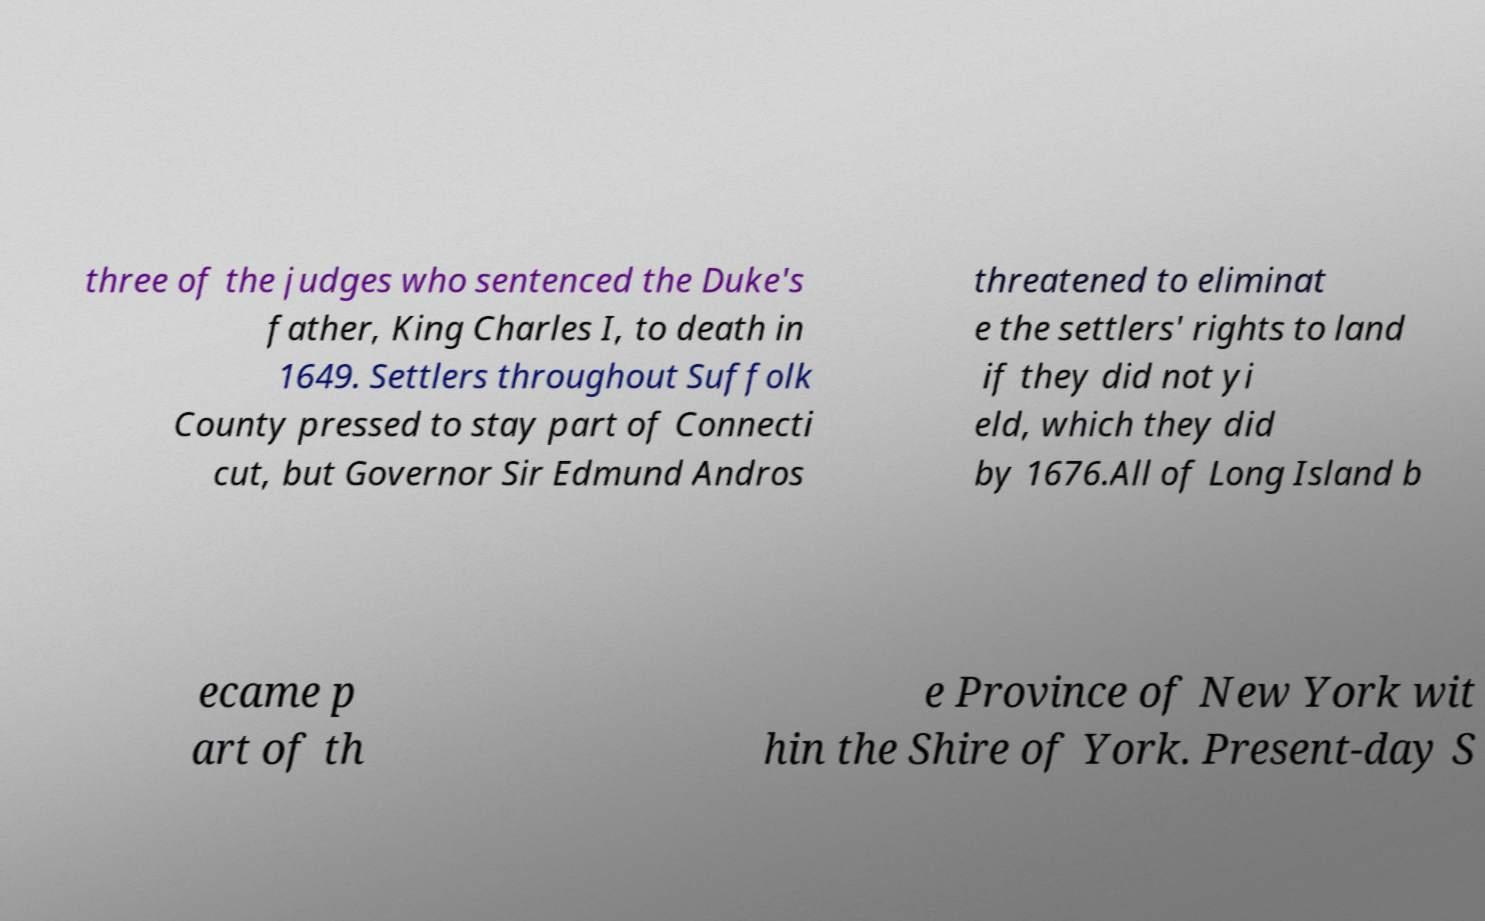Can you accurately transcribe the text from the provided image for me? three of the judges who sentenced the Duke's father, King Charles I, to death in 1649. Settlers throughout Suffolk County pressed to stay part of Connecti cut, but Governor Sir Edmund Andros threatened to eliminat e the settlers' rights to land if they did not yi eld, which they did by 1676.All of Long Island b ecame p art of th e Province of New York wit hin the Shire of York. Present-day S 